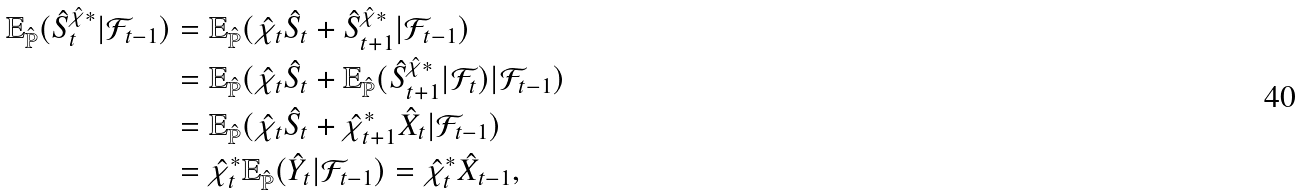<formula> <loc_0><loc_0><loc_500><loc_500>\mathbb { E } _ { \hat { \mathbb { P } } } ( \hat { S } _ { t } ^ { \hat { \chi } \ast } | \mathcal { F } _ { t - 1 } ) & = \mathbb { E } _ { \hat { \mathbb { P } } } ( \hat { \chi } _ { t } \hat { S } _ { t } + \hat { S } _ { t + 1 } ^ { \hat { \chi } \ast } | \mathcal { F } _ { t - 1 } ) \\ & = \mathbb { E } _ { \hat { \mathbb { P } } } ( \hat { \chi } _ { t } \hat { S } _ { t } + \mathbb { E } _ { \hat { \mathbb { P } } } ( \hat { S } _ { t + 1 } ^ { \hat { \chi } \ast } | \mathcal { F } _ { t } ) | \mathcal { F } _ { t - 1 } ) \\ & = \mathbb { E } _ { \hat { \mathbb { P } } } ( \hat { \chi } _ { t } \hat { S } _ { t } + \hat { \chi } _ { t + 1 } ^ { \ast } \hat { X } _ { t } | \mathcal { F } _ { t - 1 } ) \\ & = \hat { \chi } ^ { \ast } _ { t } \mathbb { E } _ { \hat { \mathbb { P } } } ( \hat { Y } _ { t } | \mathcal { F } _ { t - 1 } ) = \hat { \chi } _ { t } ^ { \ast } \hat { X } _ { t - 1 } ,</formula> 